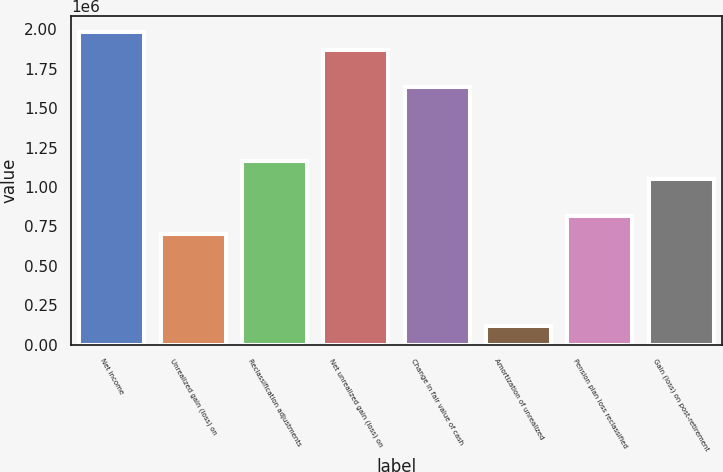Convert chart to OTSL. <chart><loc_0><loc_0><loc_500><loc_500><bar_chart><fcel>Net income<fcel>Unrealized gain (loss) on<fcel>Reclassification adjustments<fcel>Net unrealized gain (loss) on<fcel>Change in fair value of cash<fcel>Amortization of unrealized<fcel>Pension plan loss reclassified<fcel>Gain (loss) on post-retirement<nl><fcel>1.98287e+06<fcel>699846<fcel>1.1664e+06<fcel>1.86623e+06<fcel>1.63295e+06<fcel>116653<fcel>816484<fcel>1.04976e+06<nl></chart> 